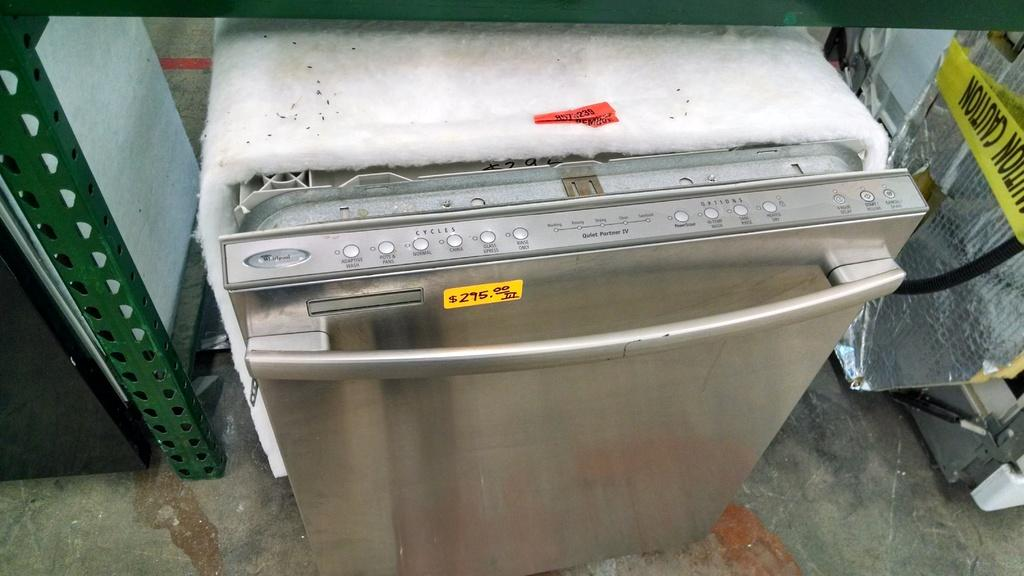Provide a one-sentence caption for the provided image. The price of this dishwasher is 295 dollars. 